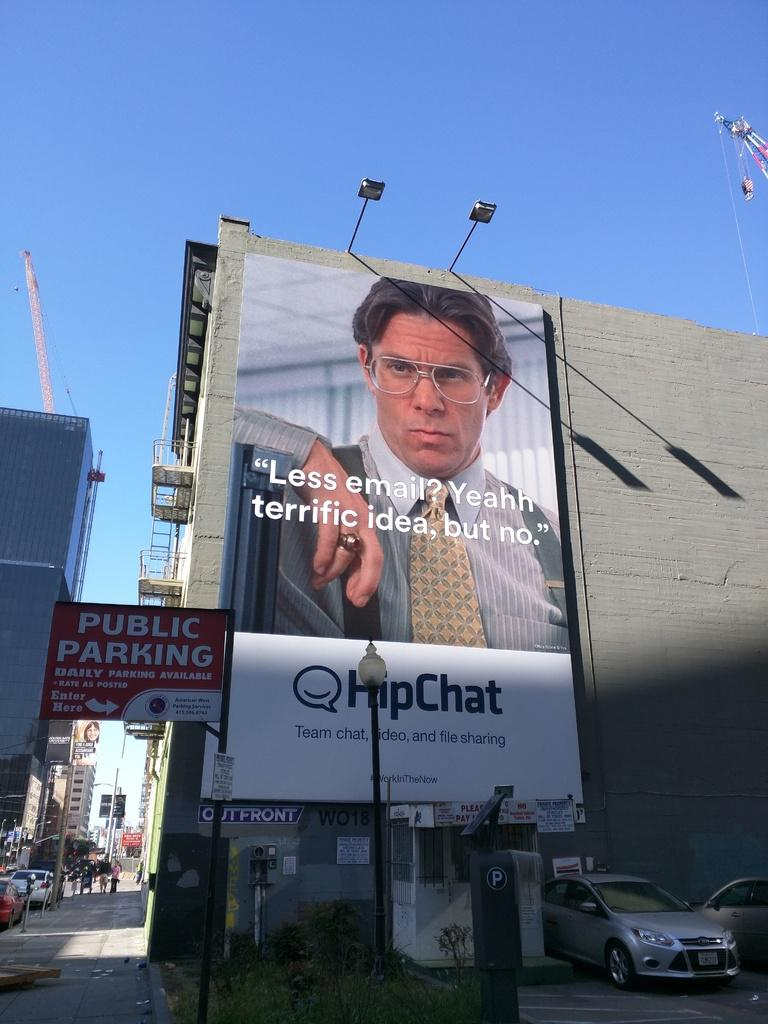What is depicted on the poster in the image? The poster contains a picture of a man. What can be seen in the background of the image? There are cars parked in the image. What is the color of the pole in the image? The pole in the image is black. What is the color of the sky in the image? The sky is blue in the image. Reasoning: Let' Let's think step by step in order to produce the conversation. We start by identifying the main subject of the image, which is the poster. Then, we describe the contents of the poster, which is a picture of a man. Next, we expand the conversation to include other elements in the image, such as the parked cars, the black pole, and the blue sky. Each question is designed to elicit a specific detail about the image that is known from the provided facts. Absurd Question/Answer: How many roses are being held by the women in the image? There are no women or roses present in the image. What type of cap is the man wearing in the image? The man in the poster is not wearing a cap; he is depicted without any headwear. How many roses are being held by the women in the image? There are no women or roses present in the image. What type of cap is the man wearing in the image? The man in the poster is not wearing a cap; he is depicted without any headwear. 